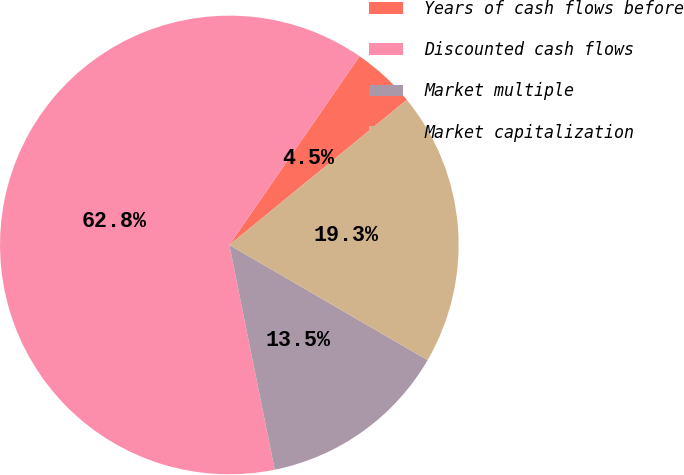<chart> <loc_0><loc_0><loc_500><loc_500><pie_chart><fcel>Years of cash flows before<fcel>Discounted cash flows<fcel>Market multiple<fcel>Market capitalization<nl><fcel>4.48%<fcel>62.78%<fcel>13.45%<fcel>19.28%<nl></chart> 